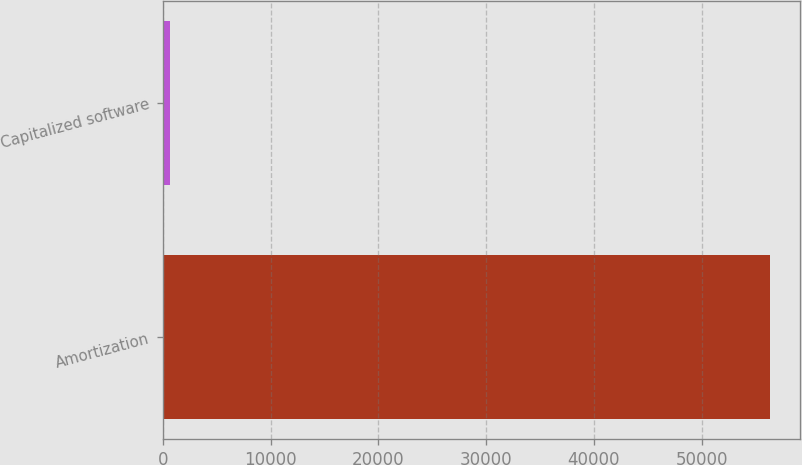<chart> <loc_0><loc_0><loc_500><loc_500><bar_chart><fcel>Amortization<fcel>Capitalized software<nl><fcel>56337<fcel>614<nl></chart> 